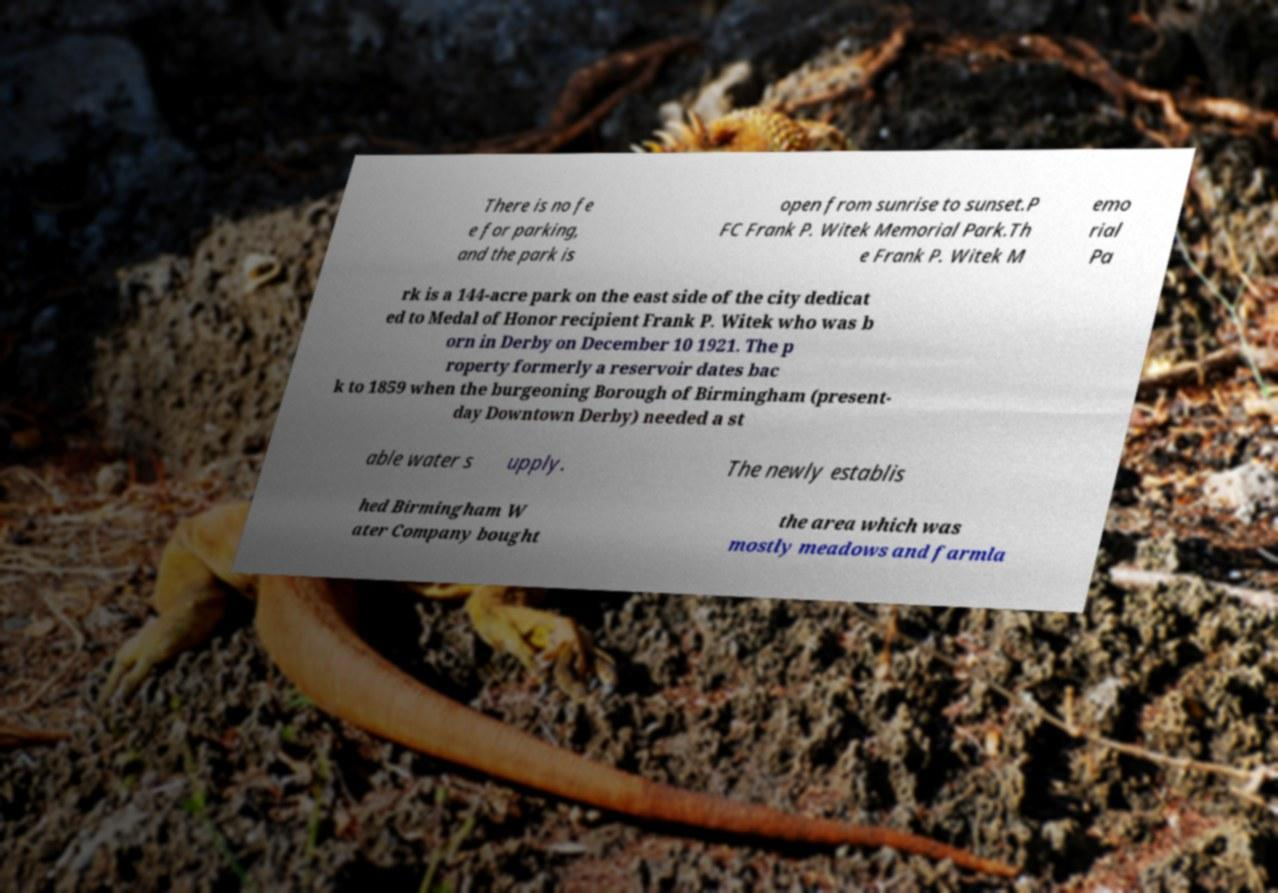What messages or text are displayed in this image? I need them in a readable, typed format. There is no fe e for parking, and the park is open from sunrise to sunset.P FC Frank P. Witek Memorial Park.Th e Frank P. Witek M emo rial Pa rk is a 144-acre park on the east side of the city dedicat ed to Medal of Honor recipient Frank P. Witek who was b orn in Derby on December 10 1921. The p roperty formerly a reservoir dates bac k to 1859 when the burgeoning Borough of Birmingham (present- day Downtown Derby) needed a st able water s upply. The newly establis hed Birmingham W ater Company bought the area which was mostly meadows and farmla 